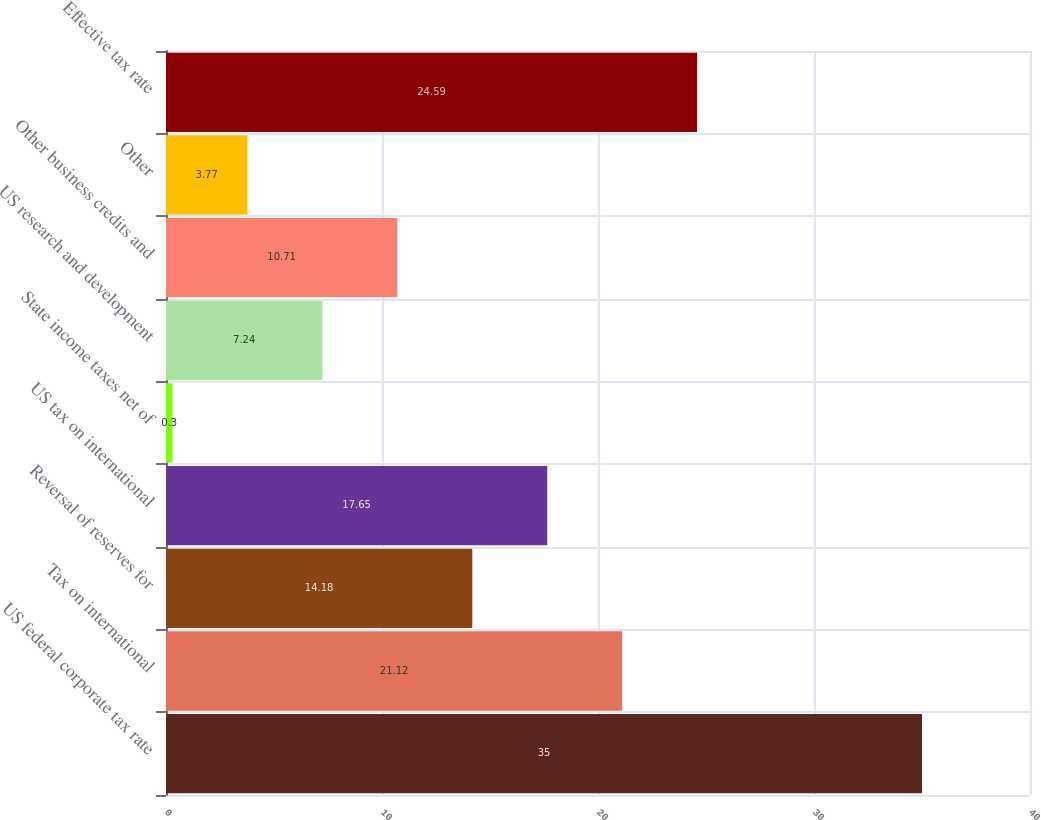<chart> <loc_0><loc_0><loc_500><loc_500><bar_chart><fcel>US federal corporate tax rate<fcel>Tax on international<fcel>Reversal of reserves for<fcel>US tax on international<fcel>State income taxes net of<fcel>US research and development<fcel>Other business credits and<fcel>Other<fcel>Effective tax rate<nl><fcel>35<fcel>21.12<fcel>14.18<fcel>17.65<fcel>0.3<fcel>7.24<fcel>10.71<fcel>3.77<fcel>24.59<nl></chart> 